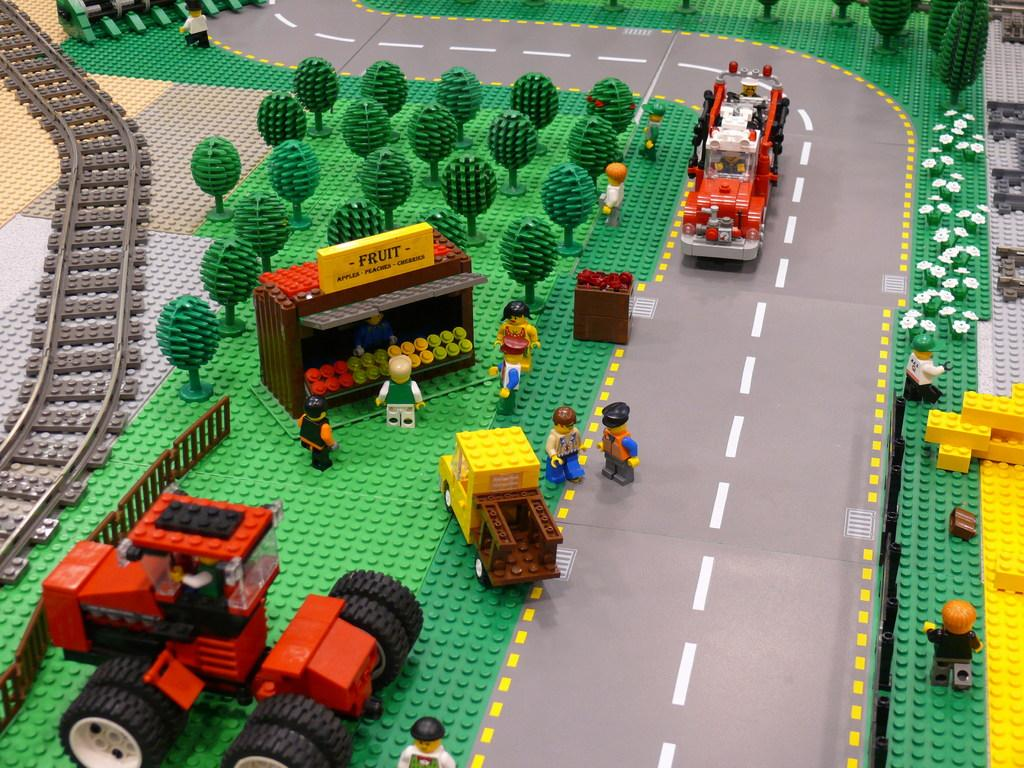<image>
Share a concise interpretation of the image provided. A Lego playmat showing market gardens and tractors and a fruit stand 